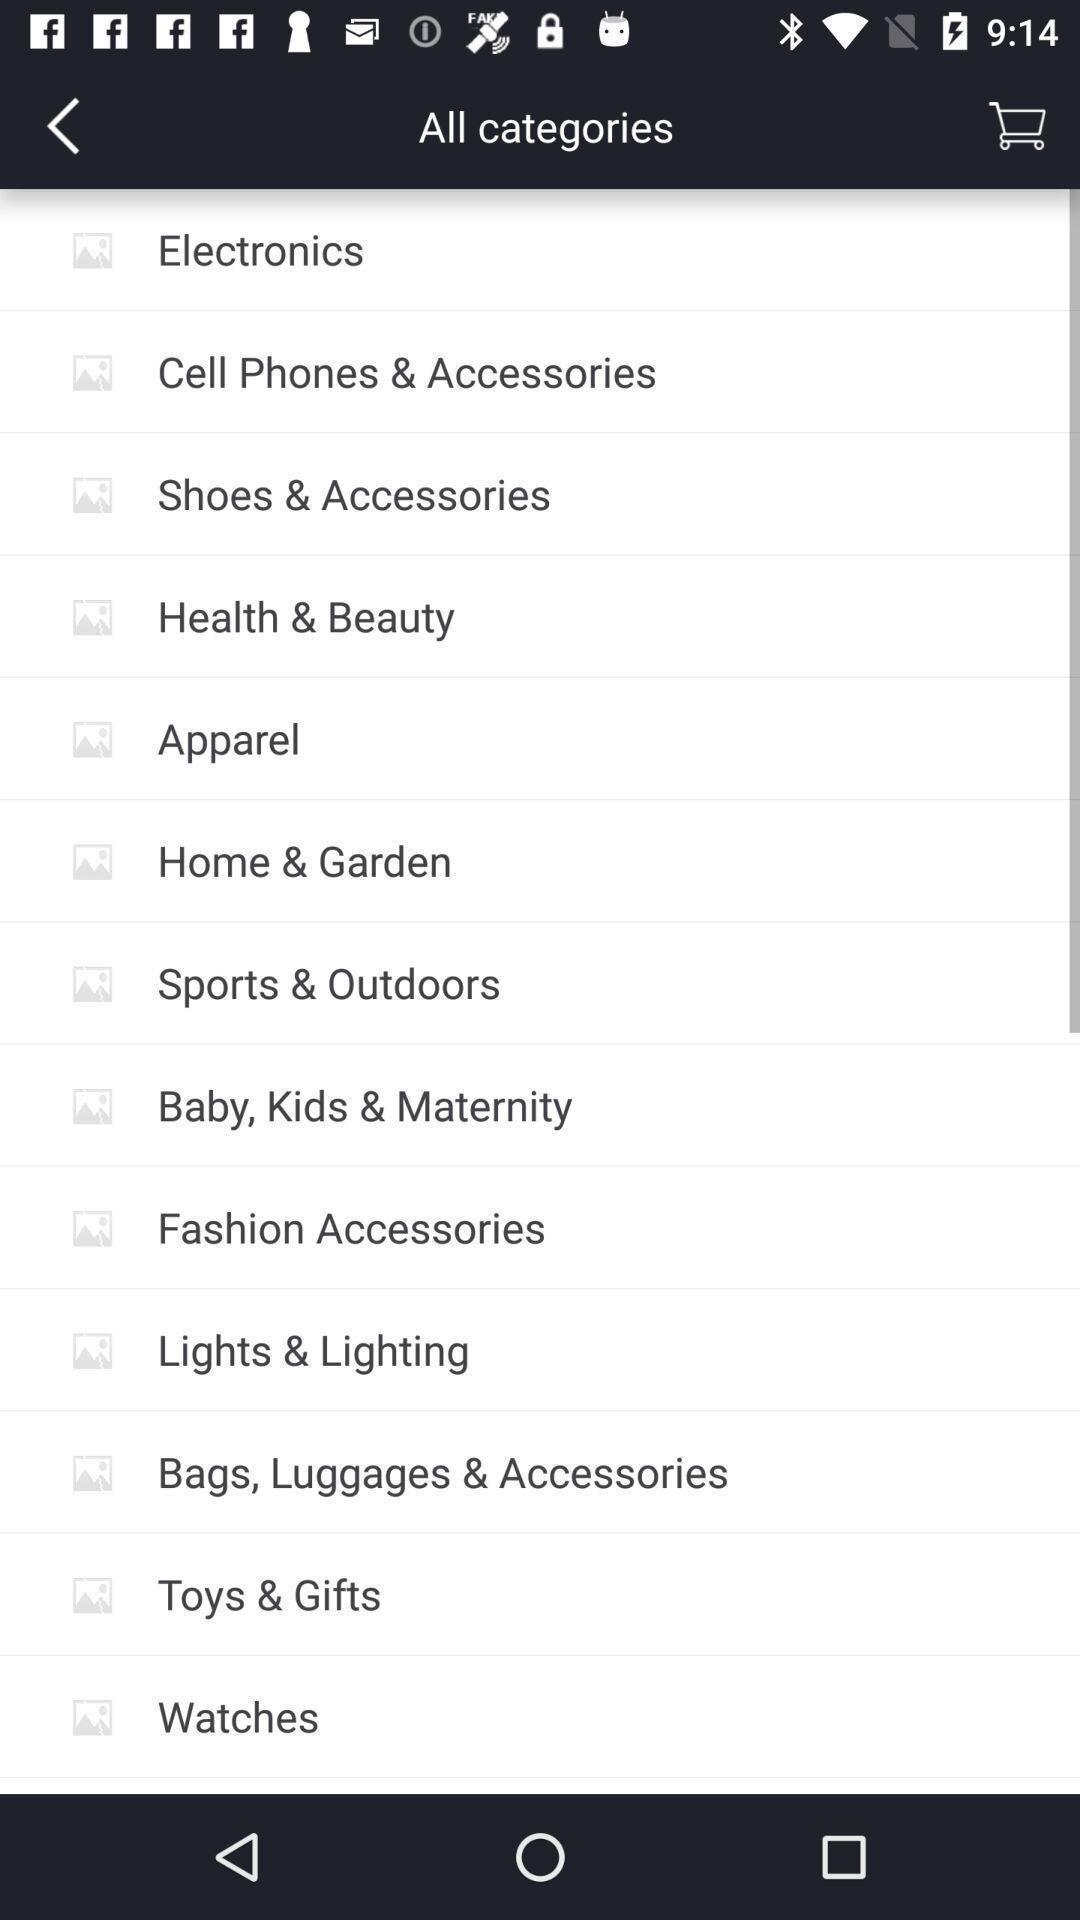Tell me what you see in this picture. Screen showing list of categories in shopping app. 